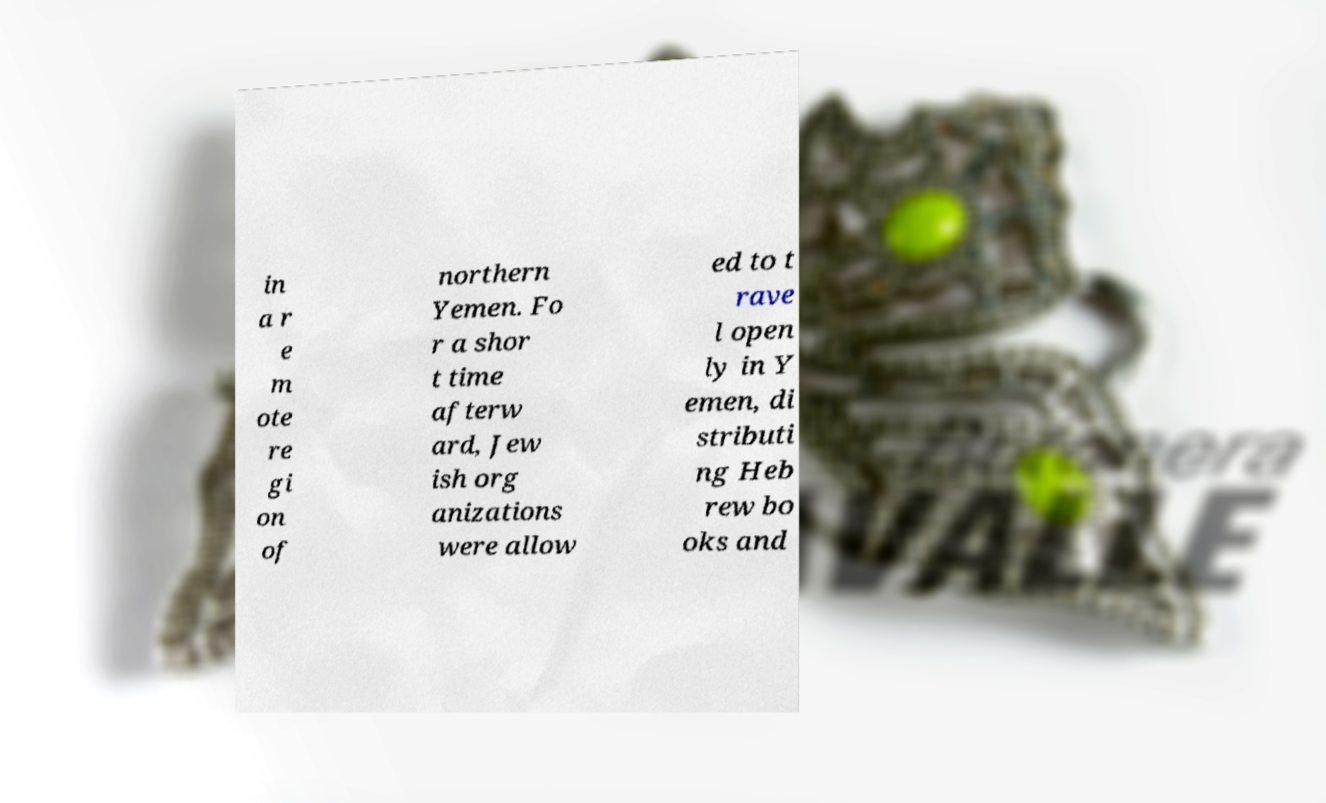Could you assist in decoding the text presented in this image and type it out clearly? in a r e m ote re gi on of northern Yemen. Fo r a shor t time afterw ard, Jew ish org anizations were allow ed to t rave l open ly in Y emen, di stributi ng Heb rew bo oks and 